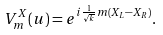<formula> <loc_0><loc_0><loc_500><loc_500>V ^ { X } _ { m } ( u ) = e ^ { i \frac { 1 } { \sqrt { k } } m ( X _ { L } - X _ { R } ) } .</formula> 